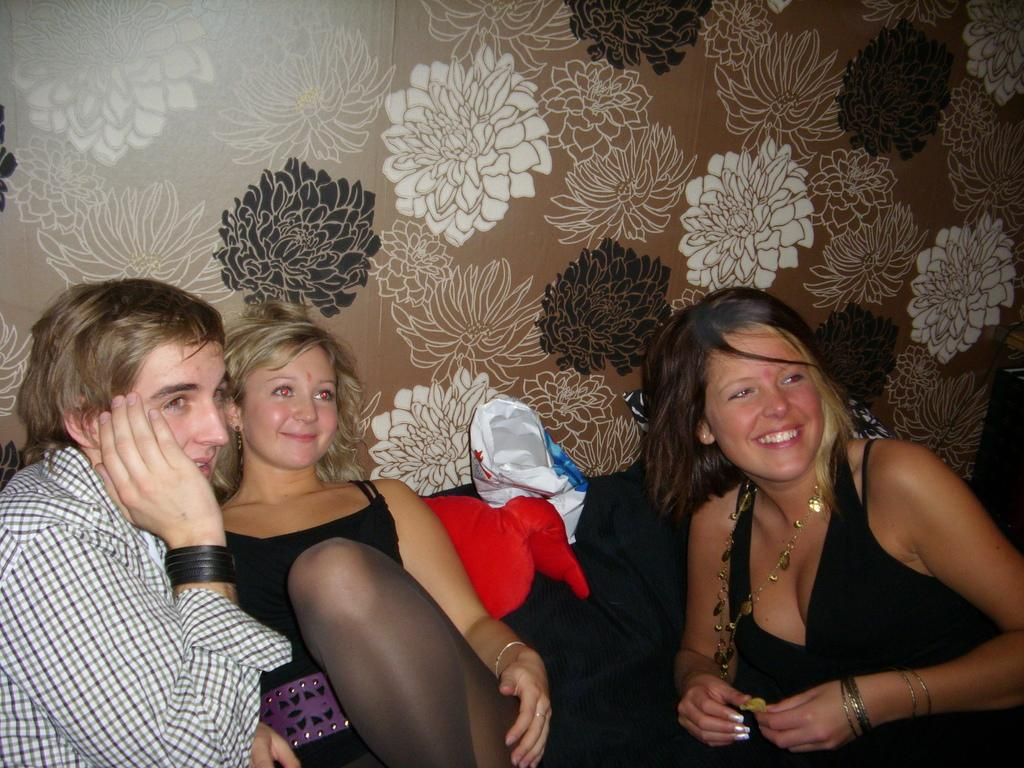How many people are in the image? There are three persons sitting in the image. Where are the persons located in the image? The persons are at the bottom of the image. What can be seen in the background of the image? There is a wall with a design in the background of the image. What type of twig is being used as a support beam in the cellar of the image? There is no mention of a cellar or a twig in the image; it only features three persons sitting and a wall with a design in the background. 